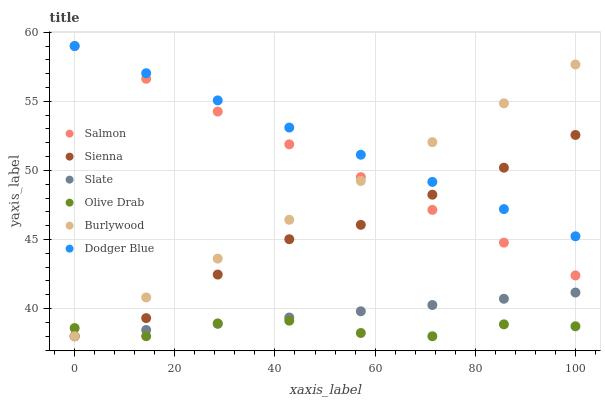Does Olive Drab have the minimum area under the curve?
Answer yes or no. Yes. Does Dodger Blue have the maximum area under the curve?
Answer yes or no. Yes. Does Slate have the minimum area under the curve?
Answer yes or no. No. Does Slate have the maximum area under the curve?
Answer yes or no. No. Is Slate the smoothest?
Answer yes or no. Yes. Is Olive Drab the roughest?
Answer yes or no. Yes. Is Salmon the smoothest?
Answer yes or no. No. Is Salmon the roughest?
Answer yes or no. No. Does Burlywood have the lowest value?
Answer yes or no. Yes. Does Salmon have the lowest value?
Answer yes or no. No. Does Dodger Blue have the highest value?
Answer yes or no. Yes. Does Slate have the highest value?
Answer yes or no. No. Is Slate less than Dodger Blue?
Answer yes or no. Yes. Is Dodger Blue greater than Olive Drab?
Answer yes or no. Yes. Does Salmon intersect Dodger Blue?
Answer yes or no. Yes. Is Salmon less than Dodger Blue?
Answer yes or no. No. Is Salmon greater than Dodger Blue?
Answer yes or no. No. Does Slate intersect Dodger Blue?
Answer yes or no. No. 